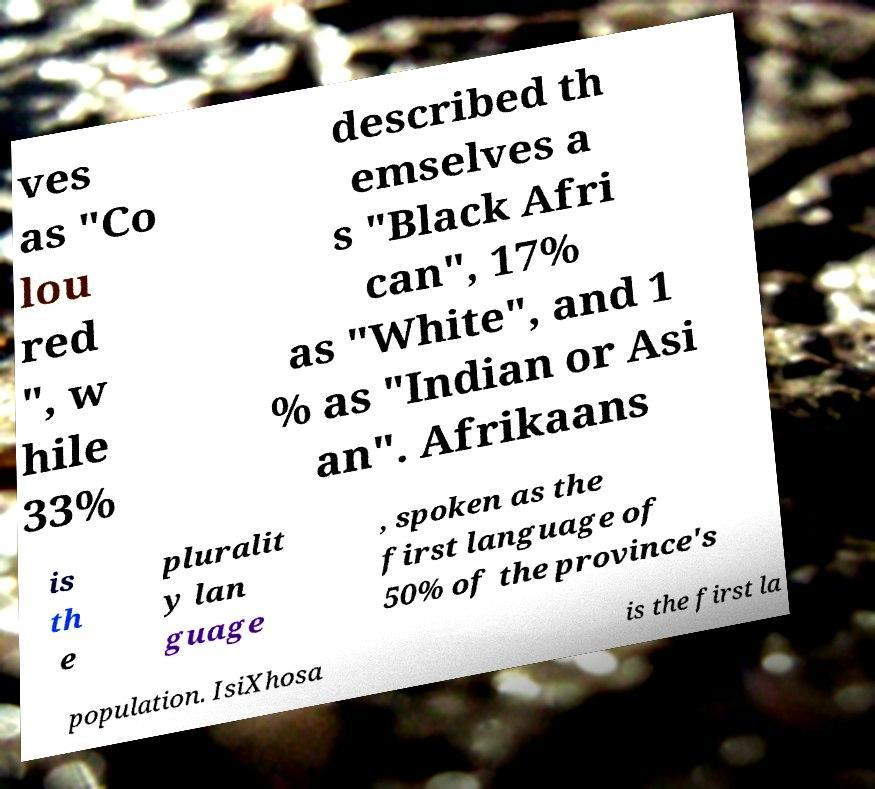For documentation purposes, I need the text within this image transcribed. Could you provide that? ves as "Co lou red ", w hile 33% described th emselves a s "Black Afri can", 17% as "White", and 1 % as "Indian or Asi an". Afrikaans is th e pluralit y lan guage , spoken as the first language of 50% of the province's population. IsiXhosa is the first la 